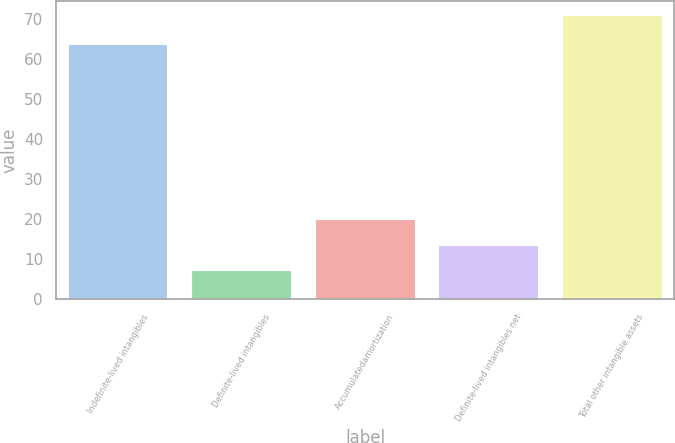<chart> <loc_0><loc_0><loc_500><loc_500><bar_chart><fcel>Indefinite-lived intangibles<fcel>Definite-lived intangibles<fcel>Accumulatedamortization<fcel>Definite-lived intangibles net<fcel>Total other intangible assets<nl><fcel>63.5<fcel>7<fcel>19.76<fcel>13.38<fcel>70.8<nl></chart> 